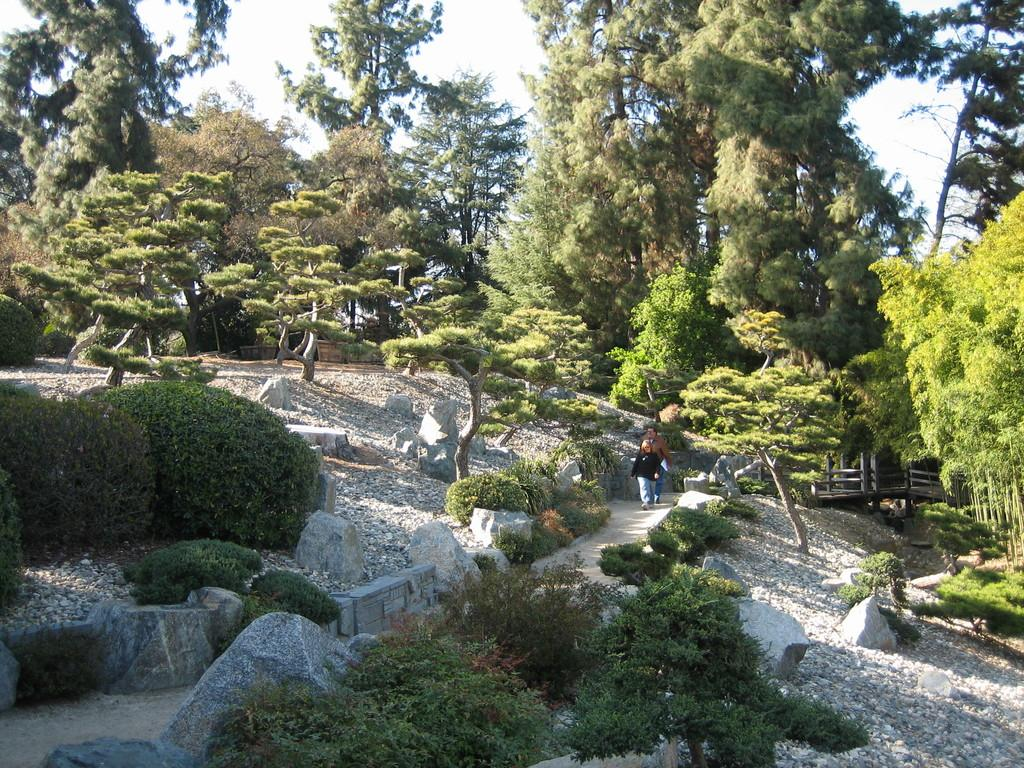How many people are in the image? There are people in the image, but the exact number is not specified. What are the people wearing? The people in the image are wearing clothes. What are the people doing in the image? The people are walking in the image. What type of natural elements can be seen in the image? There are trees, plants, and stones in the image. What man-made structure is present in the image? There is a bridge in the image. What is the color of the sky in the image? The sky is white in the image. How many pigs are jumping on the bridge in the image? There are no pigs present in the image, and therefore no such activity can be observed. Can you tell me how many frogs are sitting on the stones in the image? There are no frogs present in the image, and therefore no such activity can be observed. 